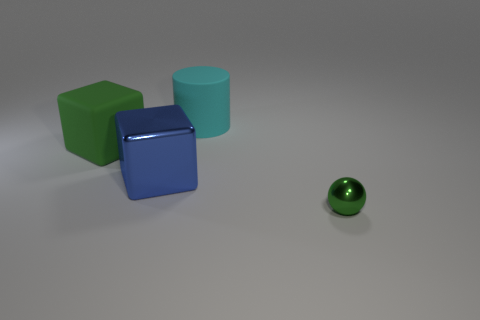Add 3 large purple blocks. How many objects exist? 7 Subtract 2 cubes. How many cubes are left? 0 Subtract all cylinders. How many objects are left? 3 Subtract all blue cubes. Subtract all gray balls. How many cubes are left? 1 Add 3 cyan cylinders. How many cyan cylinders are left? 4 Add 3 purple matte cubes. How many purple matte cubes exist? 3 Subtract 0 blue cylinders. How many objects are left? 4 Subtract all gray spheres. How many blue cubes are left? 1 Subtract all blue metallic cubes. Subtract all rubber cubes. How many objects are left? 2 